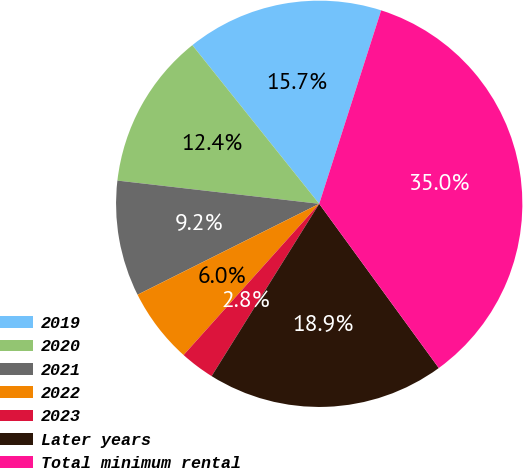<chart> <loc_0><loc_0><loc_500><loc_500><pie_chart><fcel>2019<fcel>2020<fcel>2021<fcel>2022<fcel>2023<fcel>Later years<fcel>Total minimum rental<nl><fcel>15.67%<fcel>12.44%<fcel>9.21%<fcel>5.98%<fcel>2.75%<fcel>18.9%<fcel>35.05%<nl></chart> 